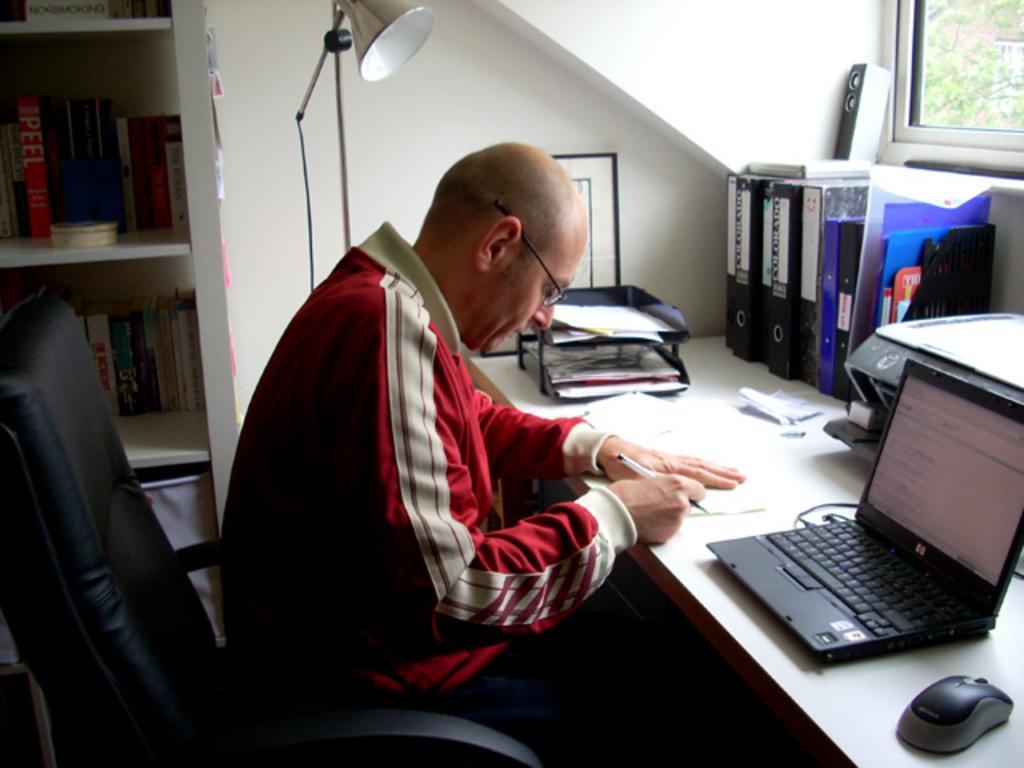Could you give a brief overview of what you see in this image? A man is sitting at table. There are laptop,mouse,some pieces of paper,file records and other items on the table. There is a lamp beside him with a stand. 